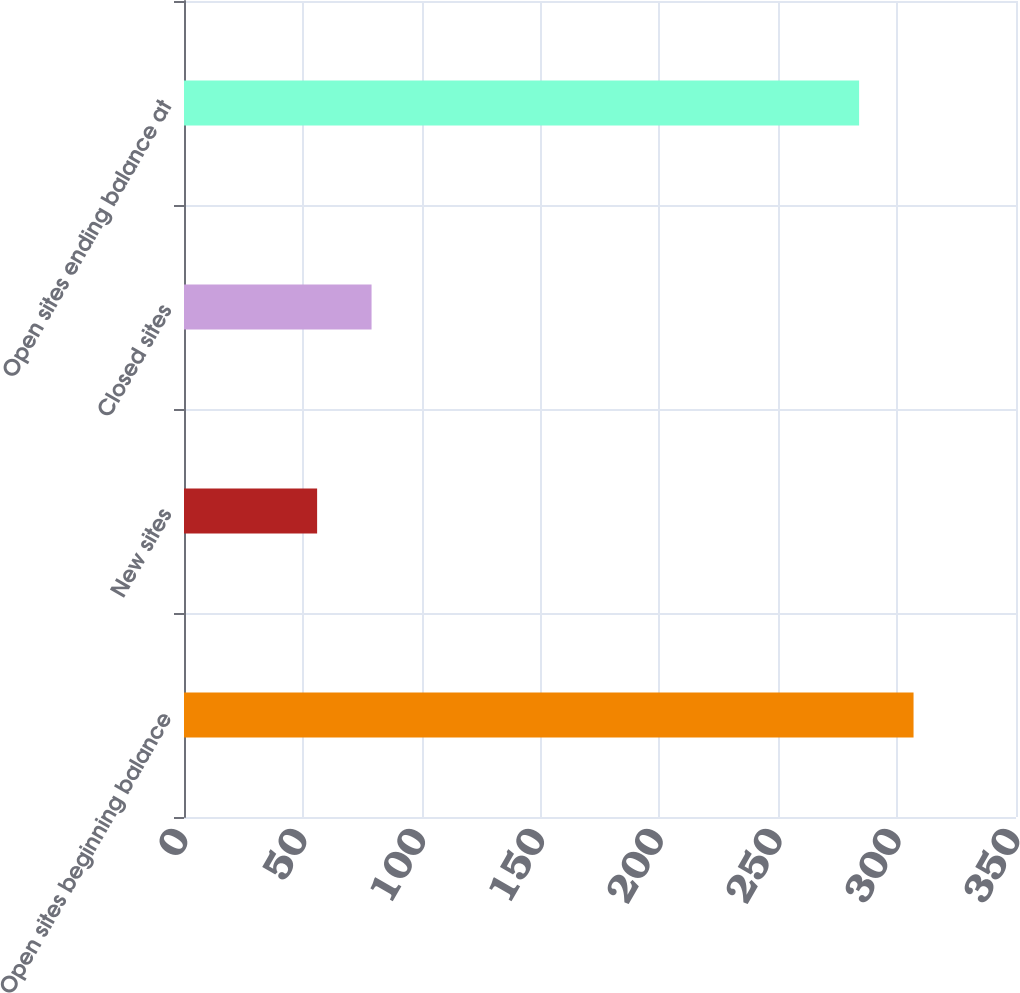<chart> <loc_0><loc_0><loc_500><loc_500><bar_chart><fcel>Open sites beginning balance<fcel>New sites<fcel>Closed sites<fcel>Open sites ending balance at<nl><fcel>306.9<fcel>56<fcel>78.9<fcel>284<nl></chart> 